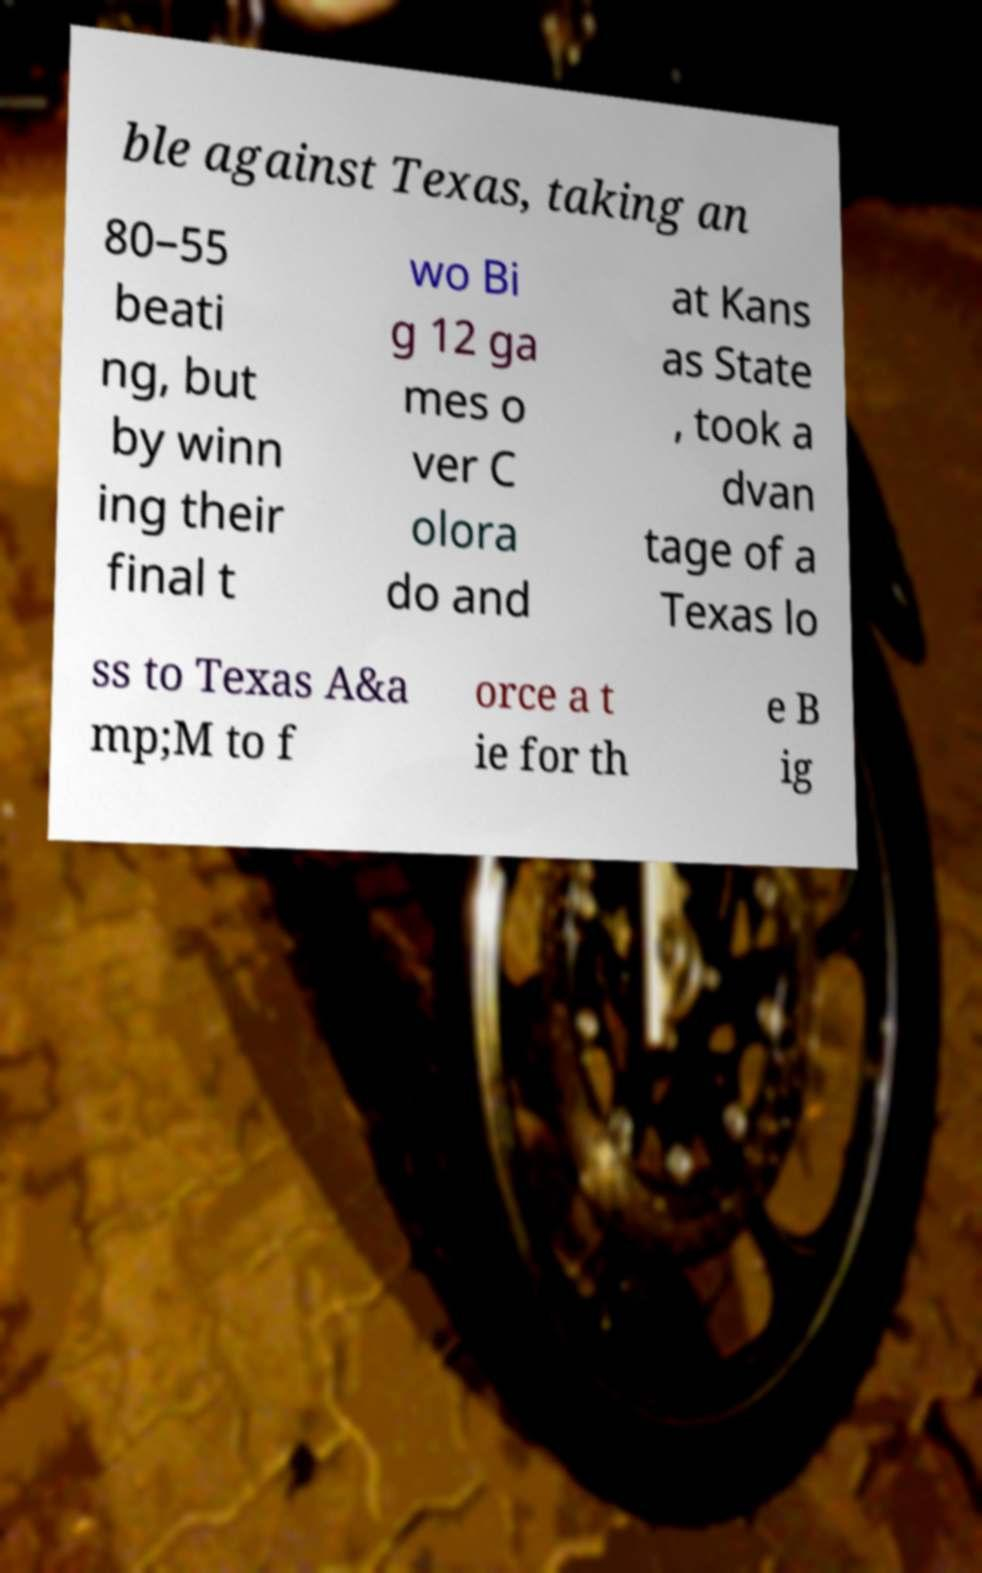I need the written content from this picture converted into text. Can you do that? ble against Texas, taking an 80–55 beati ng, but by winn ing their final t wo Bi g 12 ga mes o ver C olora do and at Kans as State , took a dvan tage of a Texas lo ss to Texas A&a mp;M to f orce a t ie for th e B ig 